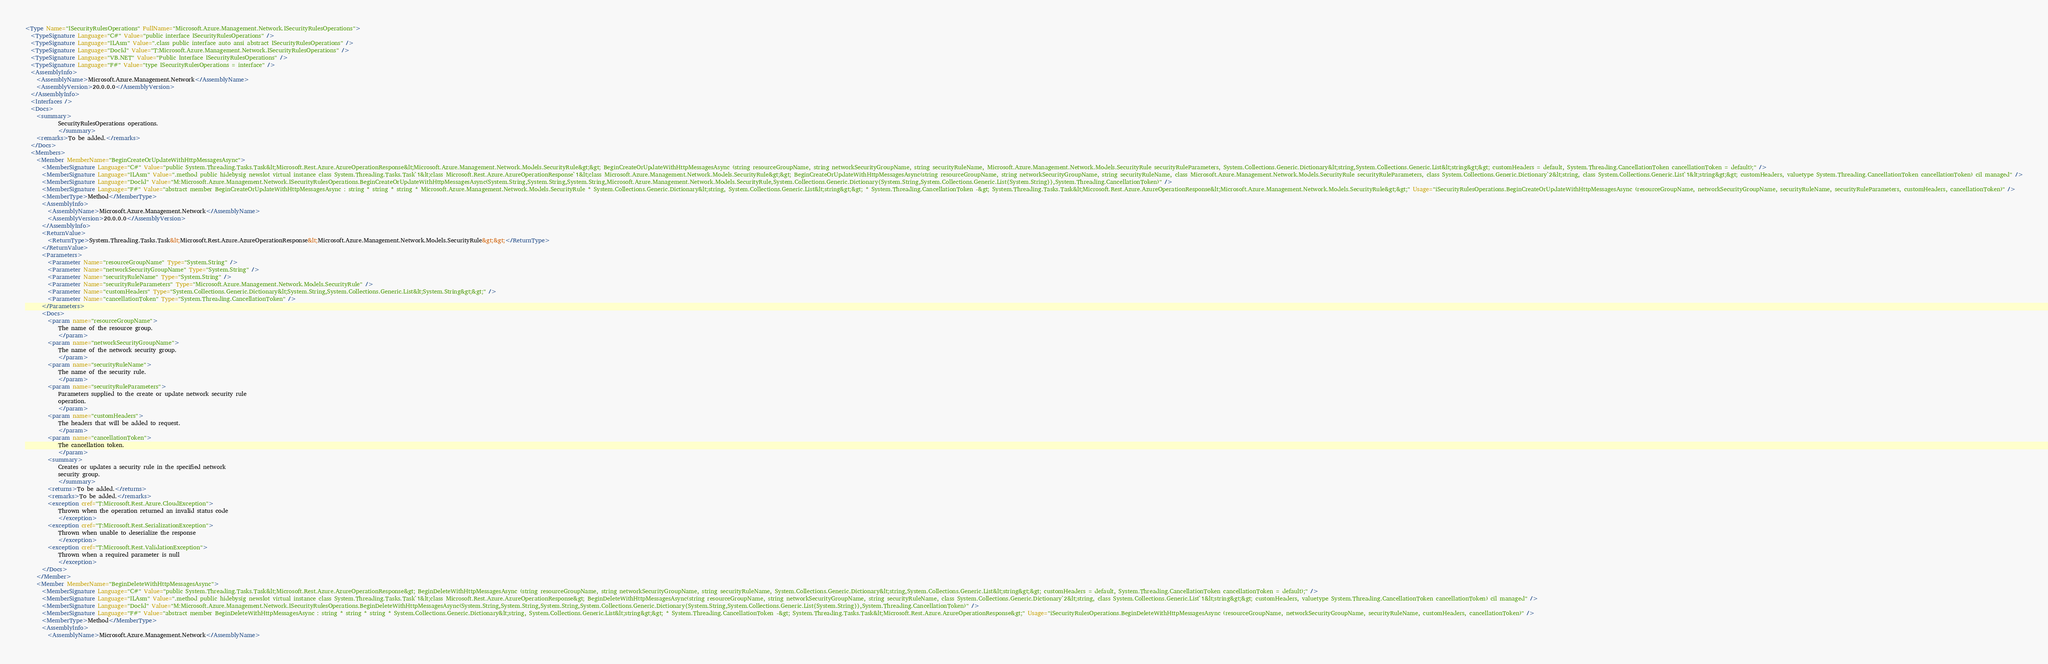Convert code to text. <code><loc_0><loc_0><loc_500><loc_500><_XML_><Type Name="ISecurityRulesOperations" FullName="Microsoft.Azure.Management.Network.ISecurityRulesOperations">
  <TypeSignature Language="C#" Value="public interface ISecurityRulesOperations" />
  <TypeSignature Language="ILAsm" Value=".class public interface auto ansi abstract ISecurityRulesOperations" />
  <TypeSignature Language="DocId" Value="T:Microsoft.Azure.Management.Network.ISecurityRulesOperations" />
  <TypeSignature Language="VB.NET" Value="Public Interface ISecurityRulesOperations" />
  <TypeSignature Language="F#" Value="type ISecurityRulesOperations = interface" />
  <AssemblyInfo>
    <AssemblyName>Microsoft.Azure.Management.Network</AssemblyName>
    <AssemblyVersion>20.0.0.0</AssemblyVersion>
  </AssemblyInfo>
  <Interfaces />
  <Docs>
    <summary>
            SecurityRulesOperations operations.
            </summary>
    <remarks>To be added.</remarks>
  </Docs>
  <Members>
    <Member MemberName="BeginCreateOrUpdateWithHttpMessagesAsync">
      <MemberSignature Language="C#" Value="public System.Threading.Tasks.Task&lt;Microsoft.Rest.Azure.AzureOperationResponse&lt;Microsoft.Azure.Management.Network.Models.SecurityRule&gt;&gt; BeginCreateOrUpdateWithHttpMessagesAsync (string resourceGroupName, string networkSecurityGroupName, string securityRuleName, Microsoft.Azure.Management.Network.Models.SecurityRule securityRuleParameters, System.Collections.Generic.Dictionary&lt;string,System.Collections.Generic.List&lt;string&gt;&gt; customHeaders = default, System.Threading.CancellationToken cancellationToken = default);" />
      <MemberSignature Language="ILAsm" Value=".method public hidebysig newslot virtual instance class System.Threading.Tasks.Task`1&lt;class Microsoft.Rest.Azure.AzureOperationResponse`1&lt;class Microsoft.Azure.Management.Network.Models.SecurityRule&gt;&gt; BeginCreateOrUpdateWithHttpMessagesAsync(string resourceGroupName, string networkSecurityGroupName, string securityRuleName, class Microsoft.Azure.Management.Network.Models.SecurityRule securityRuleParameters, class System.Collections.Generic.Dictionary`2&lt;string, class System.Collections.Generic.List`1&lt;string&gt;&gt; customHeaders, valuetype System.Threading.CancellationToken cancellationToken) cil managed" />
      <MemberSignature Language="DocId" Value="M:Microsoft.Azure.Management.Network.ISecurityRulesOperations.BeginCreateOrUpdateWithHttpMessagesAsync(System.String,System.String,System.String,Microsoft.Azure.Management.Network.Models.SecurityRule,System.Collections.Generic.Dictionary{System.String,System.Collections.Generic.List{System.String}},System.Threading.CancellationToken)" />
      <MemberSignature Language="F#" Value="abstract member BeginCreateOrUpdateWithHttpMessagesAsync : string * string * string * Microsoft.Azure.Management.Network.Models.SecurityRule * System.Collections.Generic.Dictionary&lt;string, System.Collections.Generic.List&lt;string&gt;&gt; * System.Threading.CancellationToken -&gt; System.Threading.Tasks.Task&lt;Microsoft.Rest.Azure.AzureOperationResponse&lt;Microsoft.Azure.Management.Network.Models.SecurityRule&gt;&gt;" Usage="iSecurityRulesOperations.BeginCreateOrUpdateWithHttpMessagesAsync (resourceGroupName, networkSecurityGroupName, securityRuleName, securityRuleParameters, customHeaders, cancellationToken)" />
      <MemberType>Method</MemberType>
      <AssemblyInfo>
        <AssemblyName>Microsoft.Azure.Management.Network</AssemblyName>
        <AssemblyVersion>20.0.0.0</AssemblyVersion>
      </AssemblyInfo>
      <ReturnValue>
        <ReturnType>System.Threading.Tasks.Task&lt;Microsoft.Rest.Azure.AzureOperationResponse&lt;Microsoft.Azure.Management.Network.Models.SecurityRule&gt;&gt;</ReturnType>
      </ReturnValue>
      <Parameters>
        <Parameter Name="resourceGroupName" Type="System.String" />
        <Parameter Name="networkSecurityGroupName" Type="System.String" />
        <Parameter Name="securityRuleName" Type="System.String" />
        <Parameter Name="securityRuleParameters" Type="Microsoft.Azure.Management.Network.Models.SecurityRule" />
        <Parameter Name="customHeaders" Type="System.Collections.Generic.Dictionary&lt;System.String,System.Collections.Generic.List&lt;System.String&gt;&gt;" />
        <Parameter Name="cancellationToken" Type="System.Threading.CancellationToken" />
      </Parameters>
      <Docs>
        <param name="resourceGroupName">
            The name of the resource group.
            </param>
        <param name="networkSecurityGroupName">
            The name of the network security group.
            </param>
        <param name="securityRuleName">
            The name of the security rule.
            </param>
        <param name="securityRuleParameters">
            Parameters supplied to the create or update network security rule
            operation.
            </param>
        <param name="customHeaders">
            The headers that will be added to request.
            </param>
        <param name="cancellationToken">
            The cancellation token.
            </param>
        <summary>
            Creates or updates a security rule in the specified network
            security group.
            </summary>
        <returns>To be added.</returns>
        <remarks>To be added.</remarks>
        <exception cref="T:Microsoft.Rest.Azure.CloudException">
            Thrown when the operation returned an invalid status code
            </exception>
        <exception cref="T:Microsoft.Rest.SerializationException">
            Thrown when unable to deserialize the response
            </exception>
        <exception cref="T:Microsoft.Rest.ValidationException">
            Thrown when a required parameter is null
            </exception>
      </Docs>
    </Member>
    <Member MemberName="BeginDeleteWithHttpMessagesAsync">
      <MemberSignature Language="C#" Value="public System.Threading.Tasks.Task&lt;Microsoft.Rest.Azure.AzureOperationResponse&gt; BeginDeleteWithHttpMessagesAsync (string resourceGroupName, string networkSecurityGroupName, string securityRuleName, System.Collections.Generic.Dictionary&lt;string,System.Collections.Generic.List&lt;string&gt;&gt; customHeaders = default, System.Threading.CancellationToken cancellationToken = default);" />
      <MemberSignature Language="ILAsm" Value=".method public hidebysig newslot virtual instance class System.Threading.Tasks.Task`1&lt;class Microsoft.Rest.Azure.AzureOperationResponse&gt; BeginDeleteWithHttpMessagesAsync(string resourceGroupName, string networkSecurityGroupName, string securityRuleName, class System.Collections.Generic.Dictionary`2&lt;string, class System.Collections.Generic.List`1&lt;string&gt;&gt; customHeaders, valuetype System.Threading.CancellationToken cancellationToken) cil managed" />
      <MemberSignature Language="DocId" Value="M:Microsoft.Azure.Management.Network.ISecurityRulesOperations.BeginDeleteWithHttpMessagesAsync(System.String,System.String,System.String,System.Collections.Generic.Dictionary{System.String,System.Collections.Generic.List{System.String}},System.Threading.CancellationToken)" />
      <MemberSignature Language="F#" Value="abstract member BeginDeleteWithHttpMessagesAsync : string * string * string * System.Collections.Generic.Dictionary&lt;string, System.Collections.Generic.List&lt;string&gt;&gt; * System.Threading.CancellationToken -&gt; System.Threading.Tasks.Task&lt;Microsoft.Rest.Azure.AzureOperationResponse&gt;" Usage="iSecurityRulesOperations.BeginDeleteWithHttpMessagesAsync (resourceGroupName, networkSecurityGroupName, securityRuleName, customHeaders, cancellationToken)" />
      <MemberType>Method</MemberType>
      <AssemblyInfo>
        <AssemblyName>Microsoft.Azure.Management.Network</AssemblyName></code> 